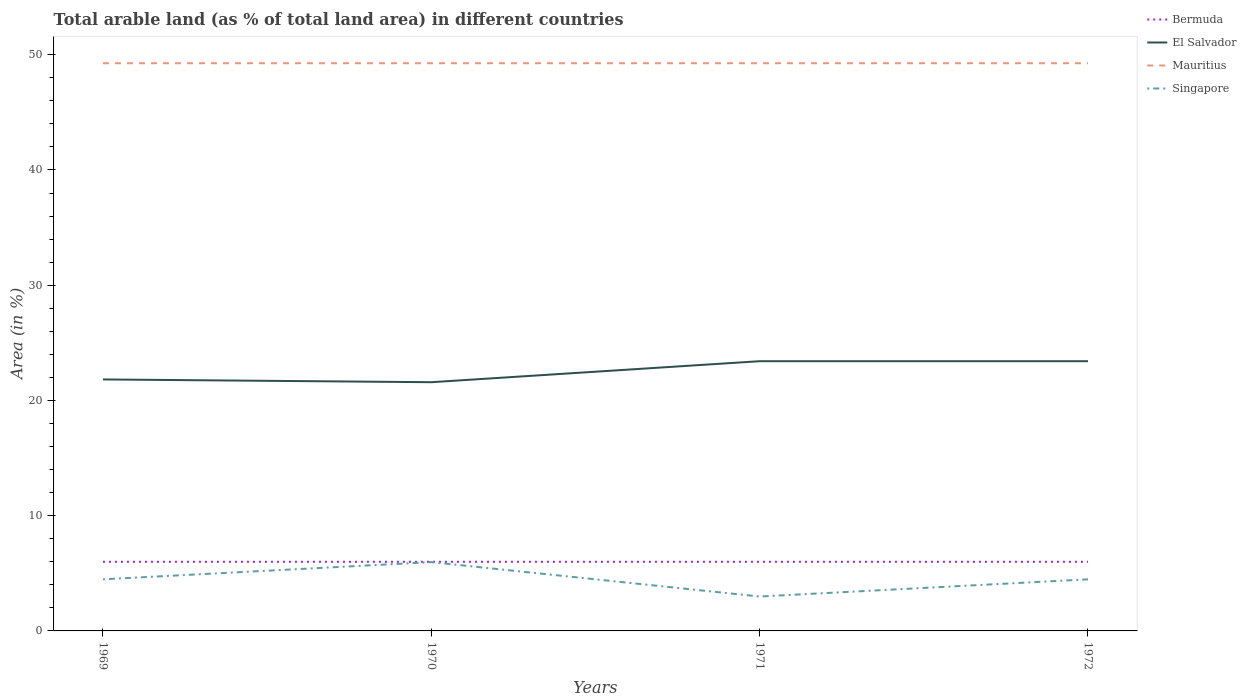How many different coloured lines are there?
Provide a short and direct response. 4. Across all years, what is the maximum percentage of arable land in Mauritius?
Your response must be concise. 49.26. In which year was the percentage of arable land in El Salvador maximum?
Give a very brief answer. 1970. What is the total percentage of arable land in El Salvador in the graph?
Provide a short and direct response. 0. What is the difference between the highest and the second highest percentage of arable land in Singapore?
Provide a succinct answer. 2.99. What is the difference between the highest and the lowest percentage of arable land in Mauritius?
Provide a short and direct response. 0. How many years are there in the graph?
Your response must be concise. 4. Are the values on the major ticks of Y-axis written in scientific E-notation?
Give a very brief answer. No. Does the graph contain grids?
Offer a very short reply. No. How many legend labels are there?
Make the answer very short. 4. What is the title of the graph?
Keep it short and to the point. Total arable land (as % of total land area) in different countries. Does "Low & middle income" appear as one of the legend labels in the graph?
Provide a succinct answer. No. What is the label or title of the Y-axis?
Provide a short and direct response. Area (in %). What is the Area (in %) of Bermuda in 1969?
Offer a very short reply. 6. What is the Area (in %) of El Salvador in 1969?
Make the answer very short. 21.82. What is the Area (in %) of Mauritius in 1969?
Give a very brief answer. 49.26. What is the Area (in %) in Singapore in 1969?
Provide a short and direct response. 4.48. What is the Area (in %) of Bermuda in 1970?
Provide a succinct answer. 6. What is the Area (in %) in El Salvador in 1970?
Provide a short and direct response. 21.58. What is the Area (in %) of Mauritius in 1970?
Ensure brevity in your answer.  49.26. What is the Area (in %) in Singapore in 1970?
Offer a terse response. 5.97. What is the Area (in %) of El Salvador in 1971?
Your response must be concise. 23.41. What is the Area (in %) of Mauritius in 1971?
Provide a short and direct response. 49.26. What is the Area (in %) in Singapore in 1971?
Ensure brevity in your answer.  2.99. What is the Area (in %) in El Salvador in 1972?
Provide a short and direct response. 23.41. What is the Area (in %) in Mauritius in 1972?
Make the answer very short. 49.26. What is the Area (in %) of Singapore in 1972?
Your response must be concise. 4.48. Across all years, what is the maximum Area (in %) in Bermuda?
Offer a very short reply. 6. Across all years, what is the maximum Area (in %) of El Salvador?
Your response must be concise. 23.41. Across all years, what is the maximum Area (in %) in Mauritius?
Ensure brevity in your answer.  49.26. Across all years, what is the maximum Area (in %) of Singapore?
Provide a succinct answer. 5.97. Across all years, what is the minimum Area (in %) of Bermuda?
Offer a very short reply. 6. Across all years, what is the minimum Area (in %) in El Salvador?
Offer a very short reply. 21.58. Across all years, what is the minimum Area (in %) in Mauritius?
Make the answer very short. 49.26. Across all years, what is the minimum Area (in %) in Singapore?
Give a very brief answer. 2.99. What is the total Area (in %) in Bermuda in the graph?
Your response must be concise. 24. What is the total Area (in %) in El Salvador in the graph?
Keep it short and to the point. 90.22. What is the total Area (in %) of Mauritius in the graph?
Give a very brief answer. 197.04. What is the total Area (in %) in Singapore in the graph?
Offer a terse response. 17.91. What is the difference between the Area (in %) in Bermuda in 1969 and that in 1970?
Your answer should be compact. 0. What is the difference between the Area (in %) of El Salvador in 1969 and that in 1970?
Make the answer very short. 0.24. What is the difference between the Area (in %) of Mauritius in 1969 and that in 1970?
Ensure brevity in your answer.  0. What is the difference between the Area (in %) of Singapore in 1969 and that in 1970?
Offer a very short reply. -1.49. What is the difference between the Area (in %) of Bermuda in 1969 and that in 1971?
Offer a very short reply. 0. What is the difference between the Area (in %) of El Salvador in 1969 and that in 1971?
Provide a short and direct response. -1.58. What is the difference between the Area (in %) of Singapore in 1969 and that in 1971?
Make the answer very short. 1.49. What is the difference between the Area (in %) of El Salvador in 1969 and that in 1972?
Provide a short and direct response. -1.58. What is the difference between the Area (in %) of Singapore in 1969 and that in 1972?
Make the answer very short. 0. What is the difference between the Area (in %) of El Salvador in 1970 and that in 1971?
Offer a terse response. -1.82. What is the difference between the Area (in %) in Singapore in 1970 and that in 1971?
Make the answer very short. 2.99. What is the difference between the Area (in %) of El Salvador in 1970 and that in 1972?
Make the answer very short. -1.82. What is the difference between the Area (in %) in Singapore in 1970 and that in 1972?
Give a very brief answer. 1.49. What is the difference between the Area (in %) of Singapore in 1971 and that in 1972?
Provide a succinct answer. -1.49. What is the difference between the Area (in %) of Bermuda in 1969 and the Area (in %) of El Salvador in 1970?
Keep it short and to the point. -15.58. What is the difference between the Area (in %) of Bermuda in 1969 and the Area (in %) of Mauritius in 1970?
Your answer should be compact. -43.26. What is the difference between the Area (in %) in Bermuda in 1969 and the Area (in %) in Singapore in 1970?
Offer a very short reply. 0.03. What is the difference between the Area (in %) in El Salvador in 1969 and the Area (in %) in Mauritius in 1970?
Provide a short and direct response. -27.44. What is the difference between the Area (in %) in El Salvador in 1969 and the Area (in %) in Singapore in 1970?
Your answer should be very brief. 15.85. What is the difference between the Area (in %) in Mauritius in 1969 and the Area (in %) in Singapore in 1970?
Make the answer very short. 43.29. What is the difference between the Area (in %) of Bermuda in 1969 and the Area (in %) of El Salvador in 1971?
Offer a terse response. -17.41. What is the difference between the Area (in %) in Bermuda in 1969 and the Area (in %) in Mauritius in 1971?
Provide a short and direct response. -43.26. What is the difference between the Area (in %) of Bermuda in 1969 and the Area (in %) of Singapore in 1971?
Offer a very short reply. 3.01. What is the difference between the Area (in %) in El Salvador in 1969 and the Area (in %) in Mauritius in 1971?
Offer a terse response. -27.44. What is the difference between the Area (in %) in El Salvador in 1969 and the Area (in %) in Singapore in 1971?
Provide a short and direct response. 18.84. What is the difference between the Area (in %) in Mauritius in 1969 and the Area (in %) in Singapore in 1971?
Provide a succinct answer. 46.28. What is the difference between the Area (in %) of Bermuda in 1969 and the Area (in %) of El Salvador in 1972?
Your answer should be very brief. -17.41. What is the difference between the Area (in %) of Bermuda in 1969 and the Area (in %) of Mauritius in 1972?
Make the answer very short. -43.26. What is the difference between the Area (in %) in Bermuda in 1969 and the Area (in %) in Singapore in 1972?
Your answer should be very brief. 1.52. What is the difference between the Area (in %) of El Salvador in 1969 and the Area (in %) of Mauritius in 1972?
Make the answer very short. -27.44. What is the difference between the Area (in %) of El Salvador in 1969 and the Area (in %) of Singapore in 1972?
Offer a terse response. 17.34. What is the difference between the Area (in %) of Mauritius in 1969 and the Area (in %) of Singapore in 1972?
Offer a very short reply. 44.78. What is the difference between the Area (in %) in Bermuda in 1970 and the Area (in %) in El Salvador in 1971?
Your answer should be very brief. -17.41. What is the difference between the Area (in %) in Bermuda in 1970 and the Area (in %) in Mauritius in 1971?
Your response must be concise. -43.26. What is the difference between the Area (in %) of Bermuda in 1970 and the Area (in %) of Singapore in 1971?
Your response must be concise. 3.01. What is the difference between the Area (in %) of El Salvador in 1970 and the Area (in %) of Mauritius in 1971?
Ensure brevity in your answer.  -27.68. What is the difference between the Area (in %) in El Salvador in 1970 and the Area (in %) in Singapore in 1971?
Your response must be concise. 18.6. What is the difference between the Area (in %) in Mauritius in 1970 and the Area (in %) in Singapore in 1971?
Ensure brevity in your answer.  46.28. What is the difference between the Area (in %) in Bermuda in 1970 and the Area (in %) in El Salvador in 1972?
Your answer should be very brief. -17.41. What is the difference between the Area (in %) in Bermuda in 1970 and the Area (in %) in Mauritius in 1972?
Your answer should be very brief. -43.26. What is the difference between the Area (in %) of Bermuda in 1970 and the Area (in %) of Singapore in 1972?
Give a very brief answer. 1.52. What is the difference between the Area (in %) in El Salvador in 1970 and the Area (in %) in Mauritius in 1972?
Provide a short and direct response. -27.68. What is the difference between the Area (in %) of El Salvador in 1970 and the Area (in %) of Singapore in 1972?
Provide a succinct answer. 17.11. What is the difference between the Area (in %) of Mauritius in 1970 and the Area (in %) of Singapore in 1972?
Provide a short and direct response. 44.78. What is the difference between the Area (in %) in Bermuda in 1971 and the Area (in %) in El Salvador in 1972?
Your answer should be very brief. -17.41. What is the difference between the Area (in %) of Bermuda in 1971 and the Area (in %) of Mauritius in 1972?
Make the answer very short. -43.26. What is the difference between the Area (in %) in Bermuda in 1971 and the Area (in %) in Singapore in 1972?
Offer a very short reply. 1.52. What is the difference between the Area (in %) in El Salvador in 1971 and the Area (in %) in Mauritius in 1972?
Keep it short and to the point. -25.86. What is the difference between the Area (in %) of El Salvador in 1971 and the Area (in %) of Singapore in 1972?
Give a very brief answer. 18.93. What is the difference between the Area (in %) of Mauritius in 1971 and the Area (in %) of Singapore in 1972?
Keep it short and to the point. 44.78. What is the average Area (in %) of Bermuda per year?
Provide a short and direct response. 6. What is the average Area (in %) of El Salvador per year?
Offer a very short reply. 22.55. What is the average Area (in %) of Mauritius per year?
Provide a short and direct response. 49.26. What is the average Area (in %) in Singapore per year?
Give a very brief answer. 4.48. In the year 1969, what is the difference between the Area (in %) of Bermuda and Area (in %) of El Salvador?
Provide a succinct answer. -15.82. In the year 1969, what is the difference between the Area (in %) of Bermuda and Area (in %) of Mauritius?
Provide a succinct answer. -43.26. In the year 1969, what is the difference between the Area (in %) in Bermuda and Area (in %) in Singapore?
Give a very brief answer. 1.52. In the year 1969, what is the difference between the Area (in %) in El Salvador and Area (in %) in Mauritius?
Your response must be concise. -27.44. In the year 1969, what is the difference between the Area (in %) in El Salvador and Area (in %) in Singapore?
Offer a terse response. 17.34. In the year 1969, what is the difference between the Area (in %) of Mauritius and Area (in %) of Singapore?
Give a very brief answer. 44.78. In the year 1970, what is the difference between the Area (in %) in Bermuda and Area (in %) in El Salvador?
Your answer should be compact. -15.58. In the year 1970, what is the difference between the Area (in %) of Bermuda and Area (in %) of Mauritius?
Ensure brevity in your answer.  -43.26. In the year 1970, what is the difference between the Area (in %) of Bermuda and Area (in %) of Singapore?
Keep it short and to the point. 0.03. In the year 1970, what is the difference between the Area (in %) in El Salvador and Area (in %) in Mauritius?
Keep it short and to the point. -27.68. In the year 1970, what is the difference between the Area (in %) in El Salvador and Area (in %) in Singapore?
Keep it short and to the point. 15.61. In the year 1970, what is the difference between the Area (in %) of Mauritius and Area (in %) of Singapore?
Provide a short and direct response. 43.29. In the year 1971, what is the difference between the Area (in %) in Bermuda and Area (in %) in El Salvador?
Make the answer very short. -17.41. In the year 1971, what is the difference between the Area (in %) of Bermuda and Area (in %) of Mauritius?
Give a very brief answer. -43.26. In the year 1971, what is the difference between the Area (in %) of Bermuda and Area (in %) of Singapore?
Offer a very short reply. 3.01. In the year 1971, what is the difference between the Area (in %) in El Salvador and Area (in %) in Mauritius?
Your answer should be very brief. -25.86. In the year 1971, what is the difference between the Area (in %) of El Salvador and Area (in %) of Singapore?
Make the answer very short. 20.42. In the year 1971, what is the difference between the Area (in %) of Mauritius and Area (in %) of Singapore?
Ensure brevity in your answer.  46.28. In the year 1972, what is the difference between the Area (in %) in Bermuda and Area (in %) in El Salvador?
Offer a terse response. -17.41. In the year 1972, what is the difference between the Area (in %) in Bermuda and Area (in %) in Mauritius?
Ensure brevity in your answer.  -43.26. In the year 1972, what is the difference between the Area (in %) in Bermuda and Area (in %) in Singapore?
Offer a terse response. 1.52. In the year 1972, what is the difference between the Area (in %) in El Salvador and Area (in %) in Mauritius?
Your response must be concise. -25.86. In the year 1972, what is the difference between the Area (in %) in El Salvador and Area (in %) in Singapore?
Ensure brevity in your answer.  18.93. In the year 1972, what is the difference between the Area (in %) of Mauritius and Area (in %) of Singapore?
Keep it short and to the point. 44.78. What is the ratio of the Area (in %) of El Salvador in 1969 to that in 1970?
Make the answer very short. 1.01. What is the ratio of the Area (in %) of El Salvador in 1969 to that in 1971?
Make the answer very short. 0.93. What is the ratio of the Area (in %) in Singapore in 1969 to that in 1971?
Provide a succinct answer. 1.5. What is the ratio of the Area (in %) in Bermuda in 1969 to that in 1972?
Ensure brevity in your answer.  1. What is the ratio of the Area (in %) of El Salvador in 1969 to that in 1972?
Give a very brief answer. 0.93. What is the ratio of the Area (in %) in Singapore in 1969 to that in 1972?
Offer a very short reply. 1. What is the ratio of the Area (in %) in Bermuda in 1970 to that in 1971?
Offer a very short reply. 1. What is the ratio of the Area (in %) of El Salvador in 1970 to that in 1971?
Your answer should be compact. 0.92. What is the ratio of the Area (in %) in Mauritius in 1970 to that in 1971?
Provide a succinct answer. 1. What is the ratio of the Area (in %) in El Salvador in 1970 to that in 1972?
Ensure brevity in your answer.  0.92. What is the ratio of the Area (in %) in Mauritius in 1970 to that in 1972?
Offer a terse response. 1. What is the ratio of the Area (in %) of Bermuda in 1971 to that in 1972?
Offer a terse response. 1. What is the ratio of the Area (in %) in El Salvador in 1971 to that in 1972?
Provide a short and direct response. 1. What is the ratio of the Area (in %) of Mauritius in 1971 to that in 1972?
Your answer should be very brief. 1. What is the difference between the highest and the second highest Area (in %) in Bermuda?
Keep it short and to the point. 0. What is the difference between the highest and the second highest Area (in %) of El Salvador?
Provide a succinct answer. 0. What is the difference between the highest and the second highest Area (in %) of Mauritius?
Your answer should be compact. 0. What is the difference between the highest and the second highest Area (in %) in Singapore?
Your response must be concise. 1.49. What is the difference between the highest and the lowest Area (in %) of El Salvador?
Give a very brief answer. 1.82. What is the difference between the highest and the lowest Area (in %) of Mauritius?
Make the answer very short. 0. What is the difference between the highest and the lowest Area (in %) of Singapore?
Provide a succinct answer. 2.99. 